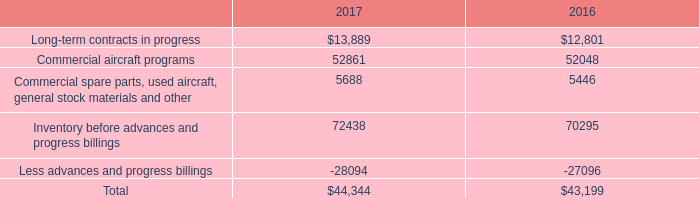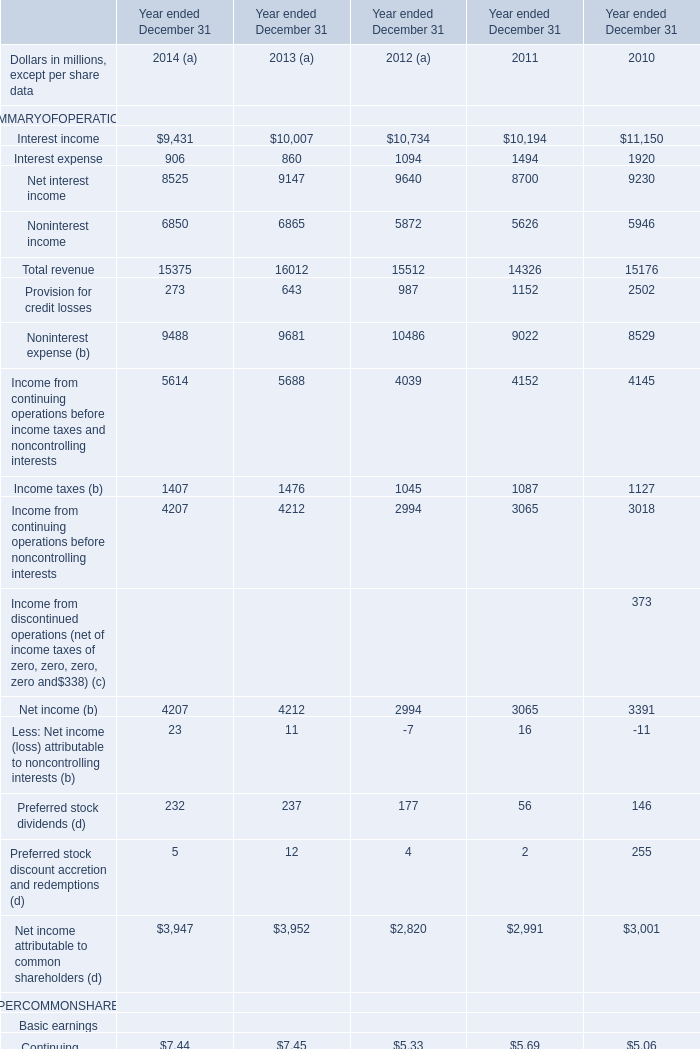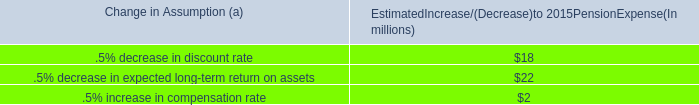In the year with largest amount of Interest income what's the increasing rate ofNoninterest income ? 
Computations: ((5626 - 5946) / 5626)
Answer: -0.05688. 